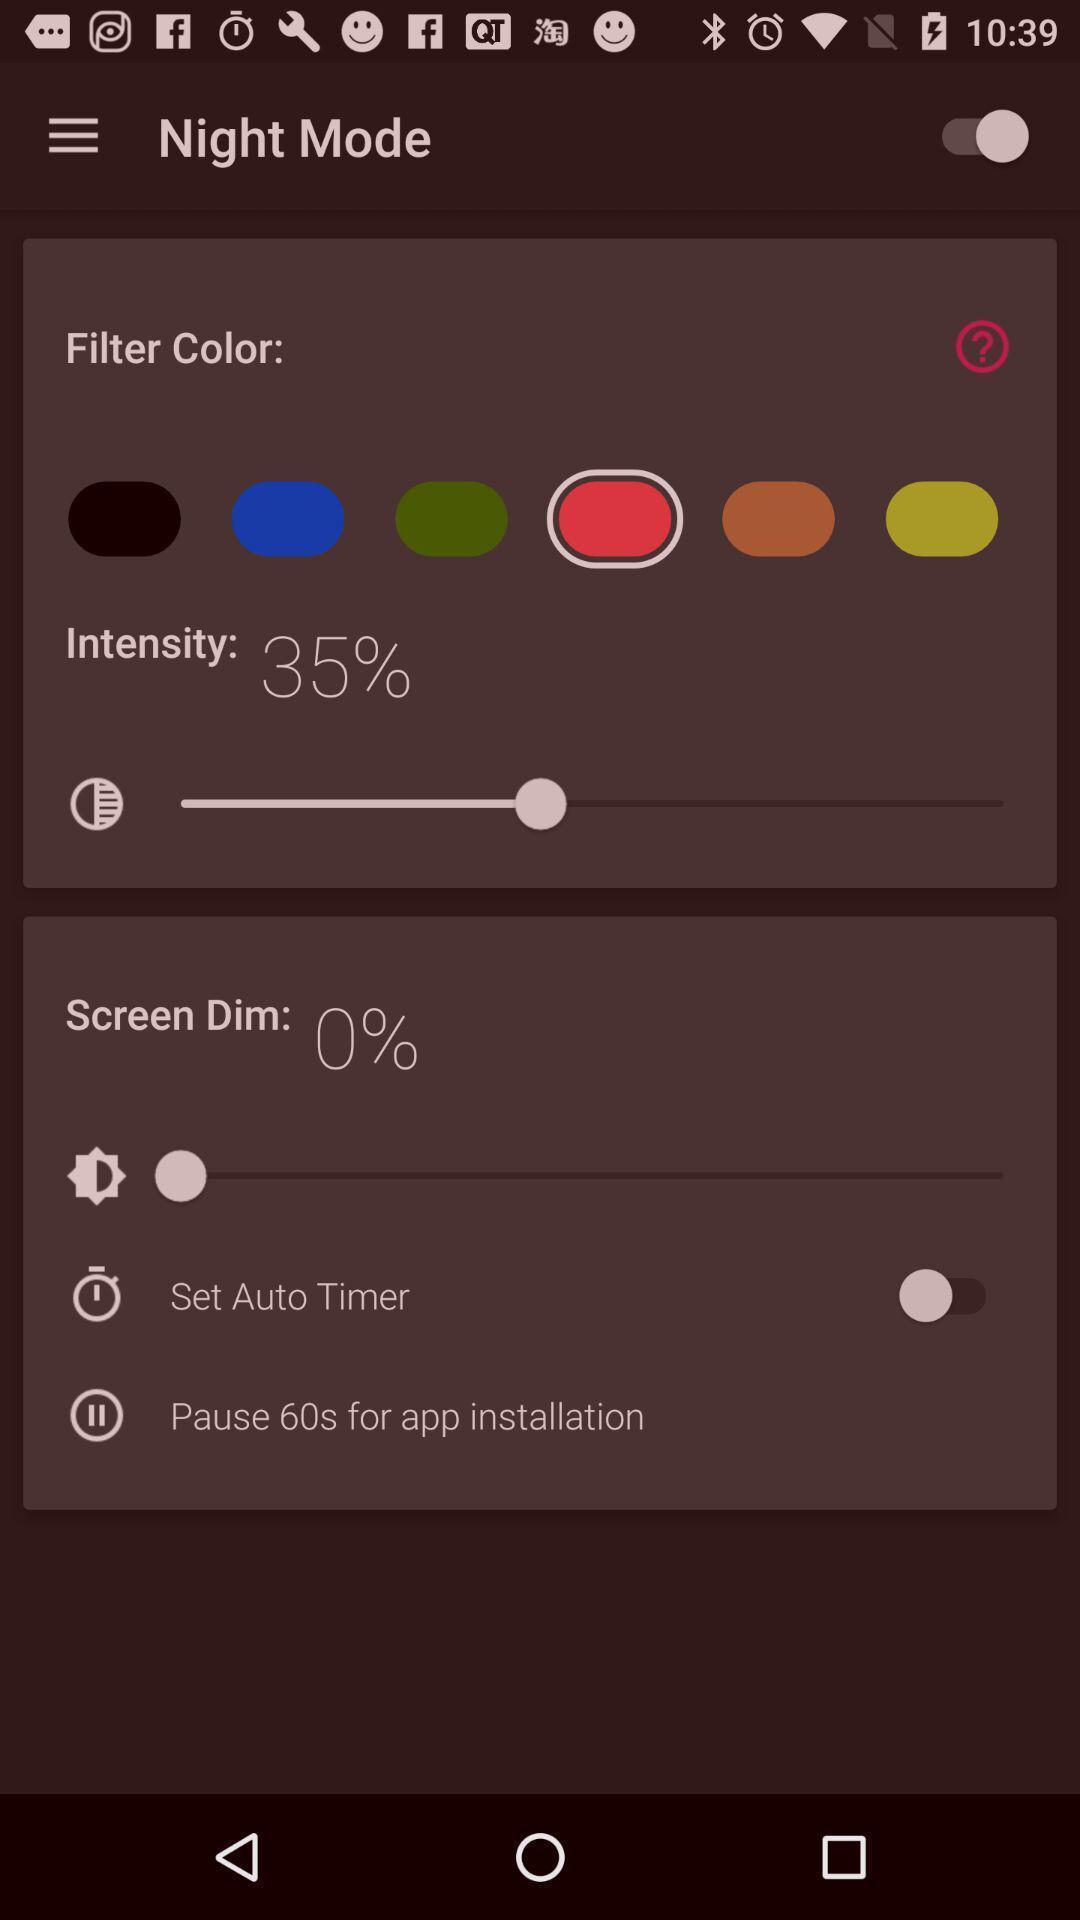Provide a detailed account of this screenshot. Screen shows night mode options. 